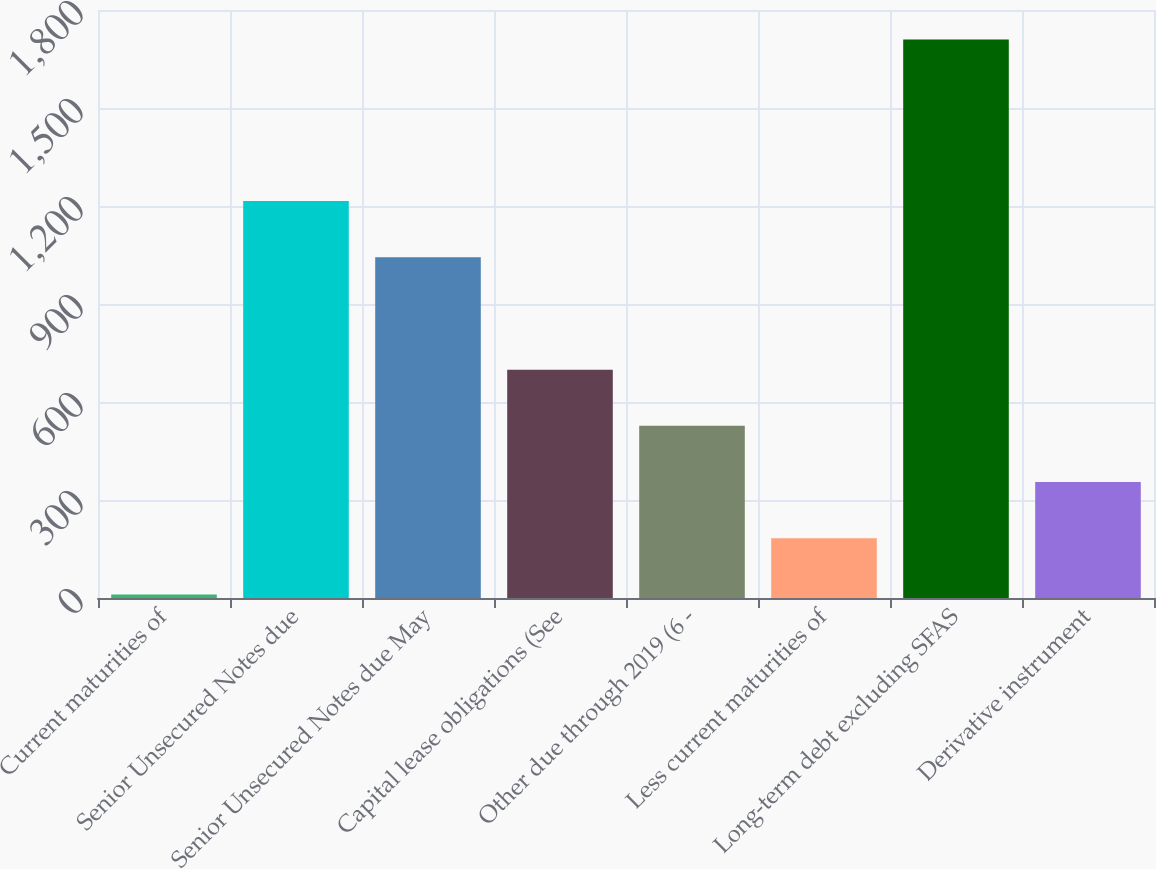Convert chart to OTSL. <chart><loc_0><loc_0><loc_500><loc_500><bar_chart><fcel>Current maturities of<fcel>Senior Unsecured Notes due<fcel>Senior Unsecured Notes due May<fcel>Capital lease obligations (See<fcel>Other due through 2019 (6 -<fcel>Less current maturities of<fcel>Long-term debt excluding SFAS<fcel>Derivative instrument<nl><fcel>11<fcel>1215<fcel>1043<fcel>699<fcel>527<fcel>183<fcel>1710<fcel>355<nl></chart> 